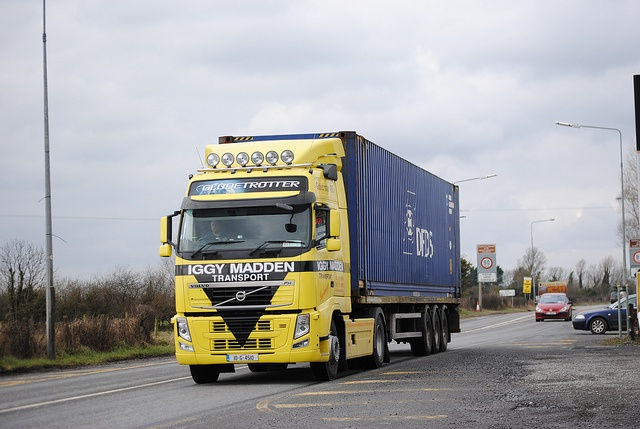Describe the objects in this image and their specific colors. I can see truck in lightgray, black, gray, and navy tones, car in lightgray, black, darkgray, gray, and navy tones, car in lightgray, darkgray, black, gray, and lightpink tones, people in lightgray, gray, and darkgray tones, and car in lightgray, gray, black, and brown tones in this image. 